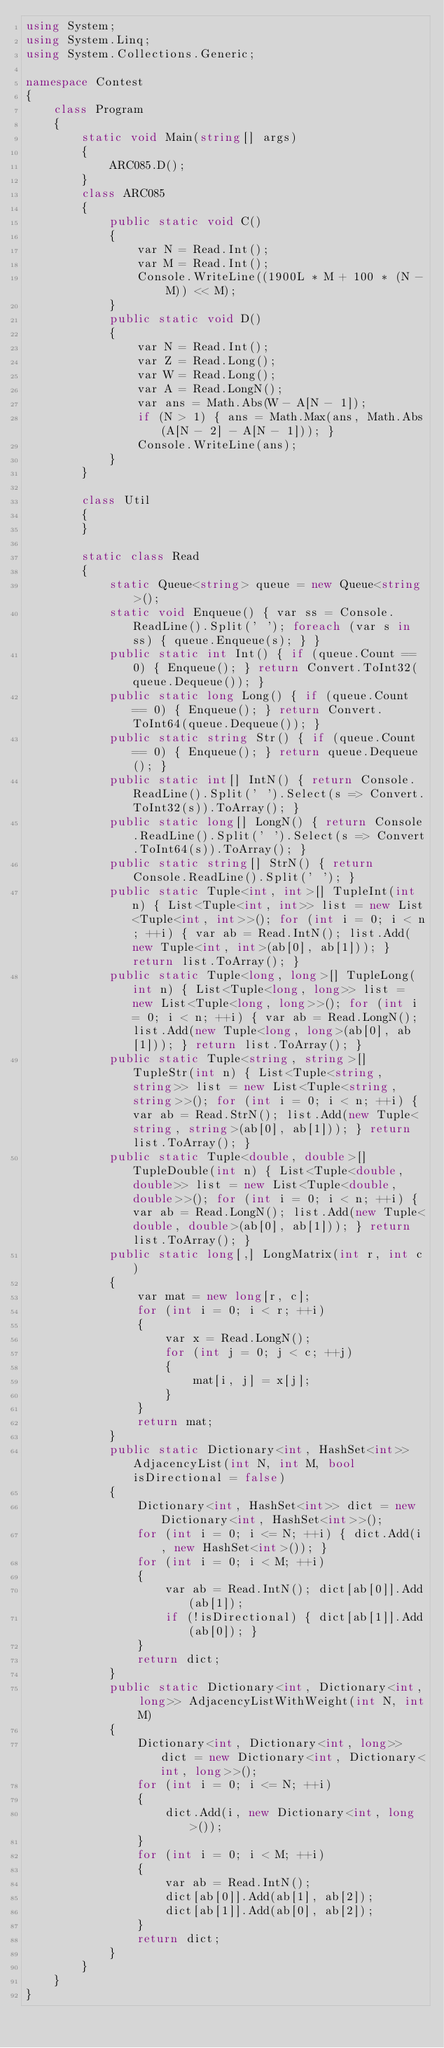<code> <loc_0><loc_0><loc_500><loc_500><_C#_>using System;
using System.Linq;
using System.Collections.Generic;

namespace Contest
{
    class Program
    {
        static void Main(string[] args)
        {
            ARC085.D();
        }
        class ARC085
        {
            public static void C()
            {
                var N = Read.Int();
                var M = Read.Int();
                Console.WriteLine((1900L * M + 100 * (N - M)) << M); 
            }
            public static void D()
            {
                var N = Read.Int();
                var Z = Read.Long();
                var W = Read.Long();
                var A = Read.LongN();
                var ans = Math.Abs(W - A[N - 1]);
                if (N > 1) { ans = Math.Max(ans, Math.Abs(A[N - 2] - A[N - 1])); }
                Console.WriteLine(ans);
            }
        }

        class Util
        {
        }

        static class Read
        {
            static Queue<string> queue = new Queue<string>();
            static void Enqueue() { var ss = Console.ReadLine().Split(' '); foreach (var s in ss) { queue.Enqueue(s); } }
            public static int Int() { if (queue.Count == 0) { Enqueue(); } return Convert.ToInt32(queue.Dequeue()); }
            public static long Long() { if (queue.Count == 0) { Enqueue(); } return Convert.ToInt64(queue.Dequeue()); }
            public static string Str() { if (queue.Count == 0) { Enqueue(); } return queue.Dequeue(); }
            public static int[] IntN() { return Console.ReadLine().Split(' ').Select(s => Convert.ToInt32(s)).ToArray(); }
            public static long[] LongN() { return Console.ReadLine().Split(' ').Select(s => Convert.ToInt64(s)).ToArray(); }
            public static string[] StrN() { return Console.ReadLine().Split(' '); }
            public static Tuple<int, int>[] TupleInt(int n) { List<Tuple<int, int>> list = new List<Tuple<int, int>>(); for (int i = 0; i < n; ++i) { var ab = Read.IntN(); list.Add(new Tuple<int, int>(ab[0], ab[1])); } return list.ToArray(); }
            public static Tuple<long, long>[] TupleLong(int n) { List<Tuple<long, long>> list = new List<Tuple<long, long>>(); for (int i = 0; i < n; ++i) { var ab = Read.LongN(); list.Add(new Tuple<long, long>(ab[0], ab[1])); } return list.ToArray(); }
            public static Tuple<string, string>[] TupleStr(int n) { List<Tuple<string, string>> list = new List<Tuple<string, string>>(); for (int i = 0; i < n; ++i) { var ab = Read.StrN(); list.Add(new Tuple<string, string>(ab[0], ab[1])); } return list.ToArray(); }
            public static Tuple<double, double>[] TupleDouble(int n) { List<Tuple<double, double>> list = new List<Tuple<double, double>>(); for (int i = 0; i < n; ++i) { var ab = Read.LongN(); list.Add(new Tuple<double, double>(ab[0], ab[1])); } return list.ToArray(); }
            public static long[,] LongMatrix(int r, int c)
            {
                var mat = new long[r, c];
                for (int i = 0; i < r; ++i)
                {
                    var x = Read.LongN();
                    for (int j = 0; j < c; ++j)
                    {
                        mat[i, j] = x[j];
                    }
                }
                return mat;
            }
            public static Dictionary<int, HashSet<int>> AdjacencyList(int N, int M, bool isDirectional = false)
            {
                Dictionary<int, HashSet<int>> dict = new Dictionary<int, HashSet<int>>();
                for (int i = 0; i <= N; ++i) { dict.Add(i, new HashSet<int>()); }
                for (int i = 0; i < M; ++i)
                {
                    var ab = Read.IntN(); dict[ab[0]].Add(ab[1]);
                    if (!isDirectional) { dict[ab[1]].Add(ab[0]); }
                }
                return dict;
            }
            public static Dictionary<int, Dictionary<int, long>> AdjacencyListWithWeight(int N, int M)
            {
                Dictionary<int, Dictionary<int, long>> dict = new Dictionary<int, Dictionary<int, long>>();
                for (int i = 0; i <= N; ++i)
                {
                    dict.Add(i, new Dictionary<int, long>());
                }
                for (int i = 0; i < M; ++i)
                {
                    var ab = Read.IntN();
                    dict[ab[0]].Add(ab[1], ab[2]);
                    dict[ab[1]].Add(ab[0], ab[2]);
                }
                return dict;
            }
        }
    }
}
</code> 